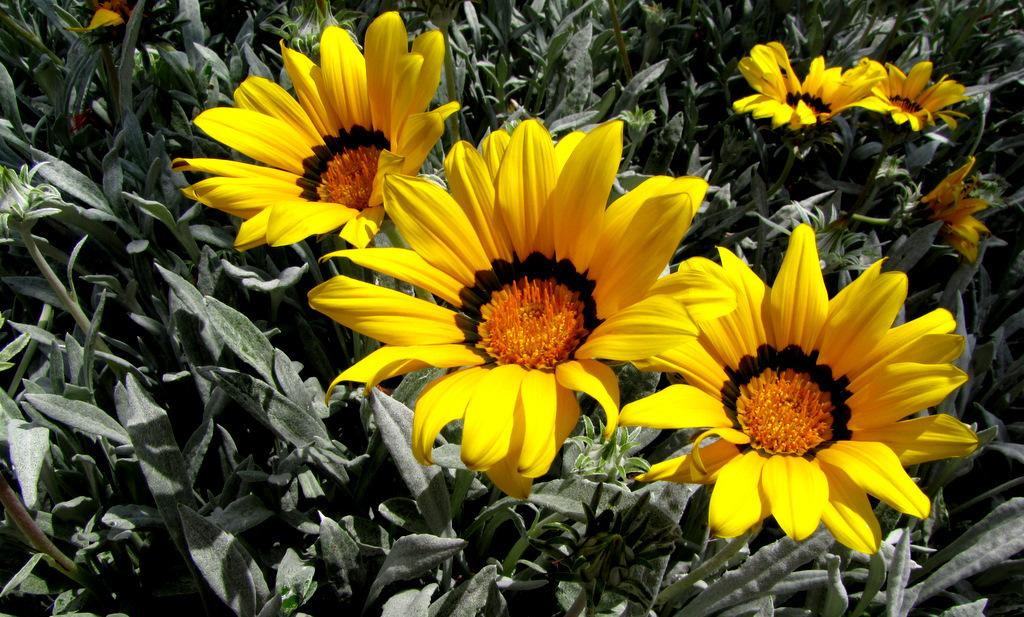What type of flowers can be seen in the image? There are yellow color flowers in the image. What else can be seen in the background of the image? There are plants in the background of the image. What is the robin teaching the students in the image? There is no robin or students present in the image; it only features yellow color flowers and plants in the background. 